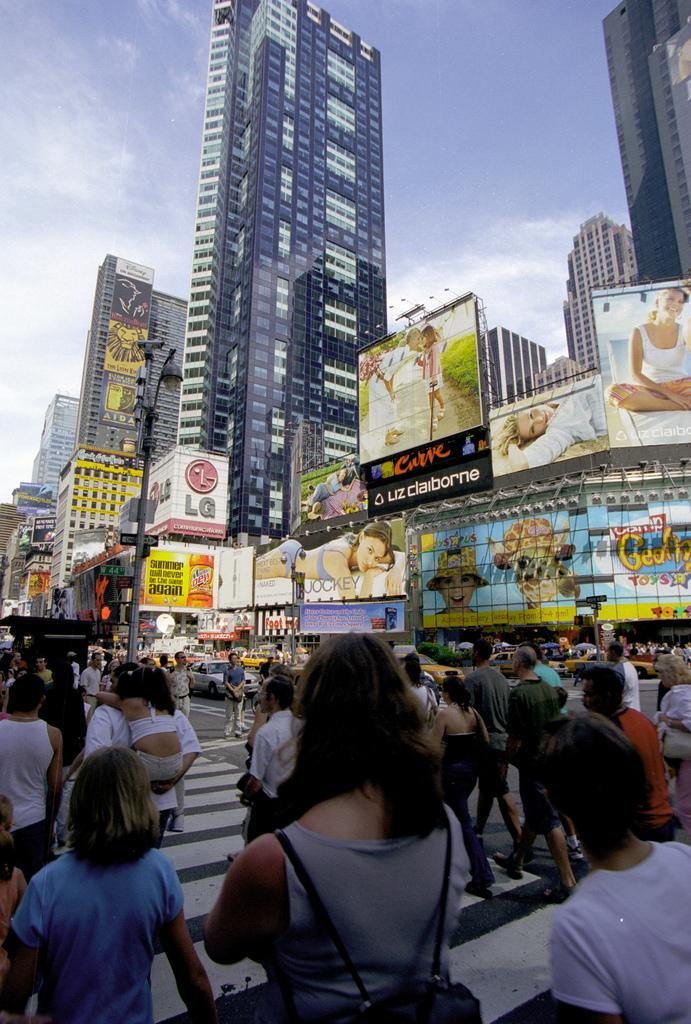What can be seen in the image? There are people, poles, lights, boards, vehicles on the road, buildings, hoardings, and the sky visible in the image. What are the poles used for? The poles are likely used to support the lights and boards in the image. What type of vehicles can be seen on the road? The specific type of vehicles cannot be determined from the image, but there are vehicles present on the road. What is visible in the background of the image? Buildings, hoardings, and the sky are visible in the background of the image. Can you tell me the value of the squirrel in the image? There is no squirrel present in the image, so it is not possible to determine its value. What is the height of the low-hanging branches in the image? There are no branches visible in the image, so it is not possible to determine the height of any low-hanging branches. 